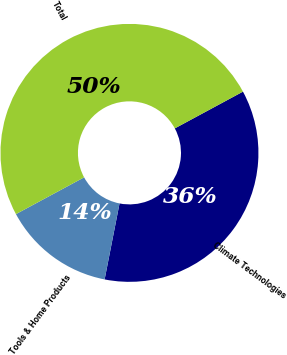<chart> <loc_0><loc_0><loc_500><loc_500><pie_chart><fcel>Climate Technologies<fcel>Tools & Home Products<fcel>Total<nl><fcel>35.96%<fcel>14.04%<fcel>50.0%<nl></chart> 